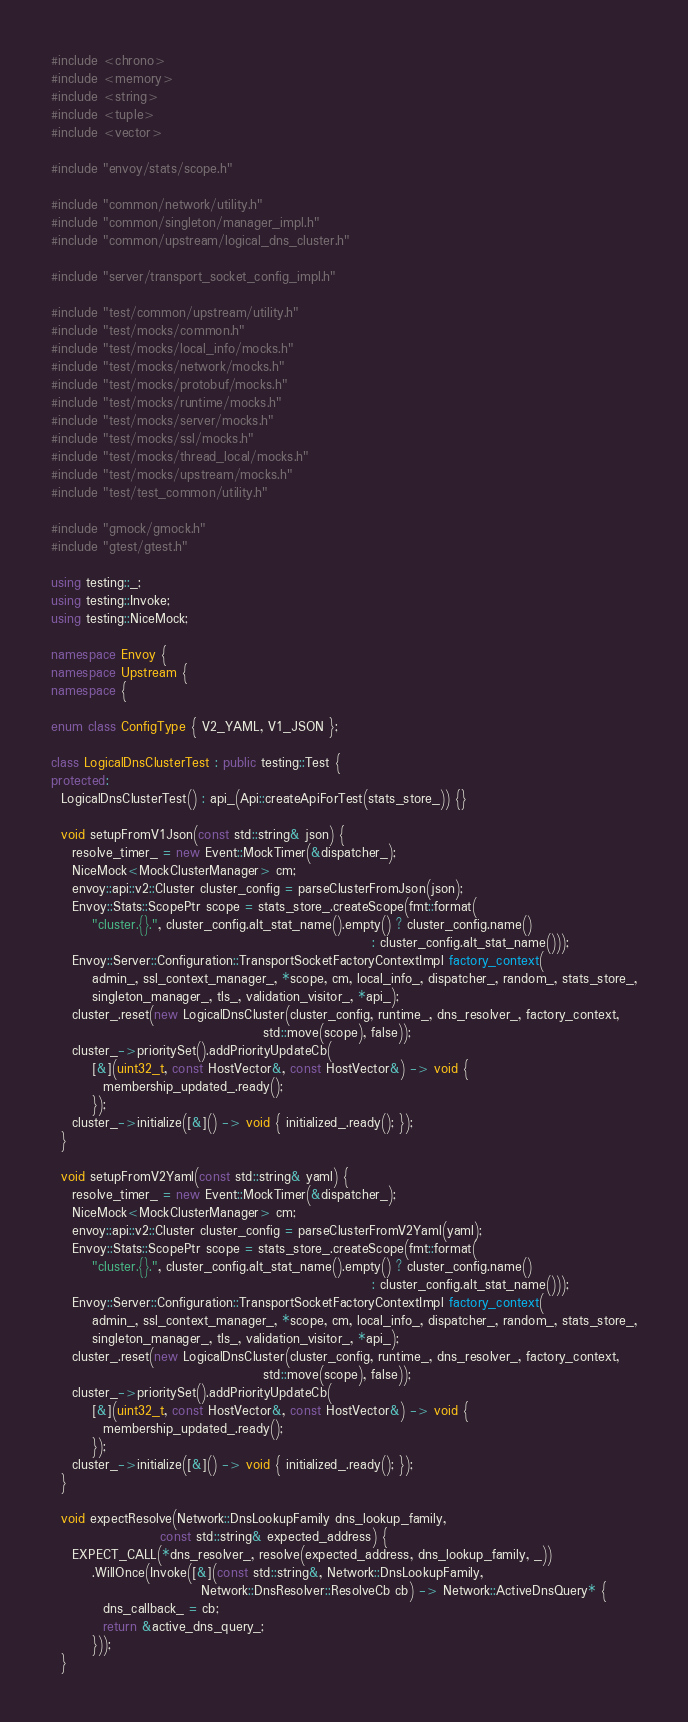Convert code to text. <code><loc_0><loc_0><loc_500><loc_500><_C++_>#include <chrono>
#include <memory>
#include <string>
#include <tuple>
#include <vector>

#include "envoy/stats/scope.h"

#include "common/network/utility.h"
#include "common/singleton/manager_impl.h"
#include "common/upstream/logical_dns_cluster.h"

#include "server/transport_socket_config_impl.h"

#include "test/common/upstream/utility.h"
#include "test/mocks/common.h"
#include "test/mocks/local_info/mocks.h"
#include "test/mocks/network/mocks.h"
#include "test/mocks/protobuf/mocks.h"
#include "test/mocks/runtime/mocks.h"
#include "test/mocks/server/mocks.h"
#include "test/mocks/ssl/mocks.h"
#include "test/mocks/thread_local/mocks.h"
#include "test/mocks/upstream/mocks.h"
#include "test/test_common/utility.h"

#include "gmock/gmock.h"
#include "gtest/gtest.h"

using testing::_;
using testing::Invoke;
using testing::NiceMock;

namespace Envoy {
namespace Upstream {
namespace {

enum class ConfigType { V2_YAML, V1_JSON };

class LogicalDnsClusterTest : public testing::Test {
protected:
  LogicalDnsClusterTest() : api_(Api::createApiForTest(stats_store_)) {}

  void setupFromV1Json(const std::string& json) {
    resolve_timer_ = new Event::MockTimer(&dispatcher_);
    NiceMock<MockClusterManager> cm;
    envoy::api::v2::Cluster cluster_config = parseClusterFromJson(json);
    Envoy::Stats::ScopePtr scope = stats_store_.createScope(fmt::format(
        "cluster.{}.", cluster_config.alt_stat_name().empty() ? cluster_config.name()
                                                              : cluster_config.alt_stat_name()));
    Envoy::Server::Configuration::TransportSocketFactoryContextImpl factory_context(
        admin_, ssl_context_manager_, *scope, cm, local_info_, dispatcher_, random_, stats_store_,
        singleton_manager_, tls_, validation_visitor_, *api_);
    cluster_.reset(new LogicalDnsCluster(cluster_config, runtime_, dns_resolver_, factory_context,
                                         std::move(scope), false));
    cluster_->prioritySet().addPriorityUpdateCb(
        [&](uint32_t, const HostVector&, const HostVector&) -> void {
          membership_updated_.ready();
        });
    cluster_->initialize([&]() -> void { initialized_.ready(); });
  }

  void setupFromV2Yaml(const std::string& yaml) {
    resolve_timer_ = new Event::MockTimer(&dispatcher_);
    NiceMock<MockClusterManager> cm;
    envoy::api::v2::Cluster cluster_config = parseClusterFromV2Yaml(yaml);
    Envoy::Stats::ScopePtr scope = stats_store_.createScope(fmt::format(
        "cluster.{}.", cluster_config.alt_stat_name().empty() ? cluster_config.name()
                                                              : cluster_config.alt_stat_name()));
    Envoy::Server::Configuration::TransportSocketFactoryContextImpl factory_context(
        admin_, ssl_context_manager_, *scope, cm, local_info_, dispatcher_, random_, stats_store_,
        singleton_manager_, tls_, validation_visitor_, *api_);
    cluster_.reset(new LogicalDnsCluster(cluster_config, runtime_, dns_resolver_, factory_context,
                                         std::move(scope), false));
    cluster_->prioritySet().addPriorityUpdateCb(
        [&](uint32_t, const HostVector&, const HostVector&) -> void {
          membership_updated_.ready();
        });
    cluster_->initialize([&]() -> void { initialized_.ready(); });
  }

  void expectResolve(Network::DnsLookupFamily dns_lookup_family,
                     const std::string& expected_address) {
    EXPECT_CALL(*dns_resolver_, resolve(expected_address, dns_lookup_family, _))
        .WillOnce(Invoke([&](const std::string&, Network::DnsLookupFamily,
                             Network::DnsResolver::ResolveCb cb) -> Network::ActiveDnsQuery* {
          dns_callback_ = cb;
          return &active_dns_query_;
        }));
  }
</code> 